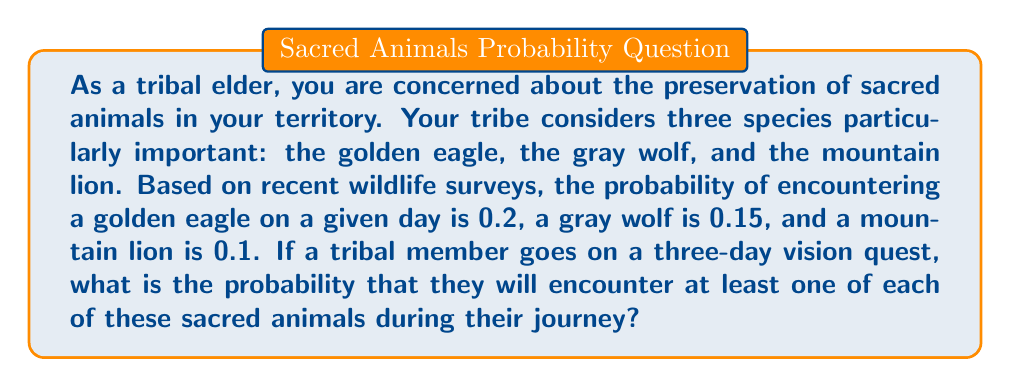Show me your answer to this math problem. Let's approach this step-by-step:

1) First, we need to calculate the probability of not encountering each animal on a single day:
   - P(no eagle) = 1 - 0.2 = 0.8
   - P(no wolf) = 1 - 0.15 = 0.85
   - P(no lion) = 1 - 0.1 = 0.9

2) Now, for a three-day period, the probability of not encountering each animal at all is:
   - P(no eagle in 3 days) = $0.8^3 = 0.512$
   - P(no wolf in 3 days) = $0.85^3 \approx 0.614125$
   - P(no lion in 3 days) = $0.9^3 = 0.729$

3) The probability of encountering each animal at least once is the opposite of not encountering it at all:
   - P(at least one eagle) = 1 - 0.512 = 0.488
   - P(at least one wolf) = 1 - 0.614125 ≈ 0.385875
   - P(at least one lion) = 1 - 0.729 = 0.271

4) The question asks for the probability of encountering at least one of each animal. This is equivalent to the probability of encountering at least one eagle AND at least one wolf AND at least one lion.

5) Since these events are independent, we multiply these probabilities:

   $$P(\text{at least one of each}) = 0.488 \times 0.385875 \times 0.271 \approx 0.0510$$

6) Converting to a percentage: $0.0510 \times 100\% = 5.10\%$
Answer: The probability that a tribal member will encounter at least one of each sacred animal (golden eagle, gray wolf, and mountain lion) during a three-day vision quest is approximately 5.10% or 0.0510. 